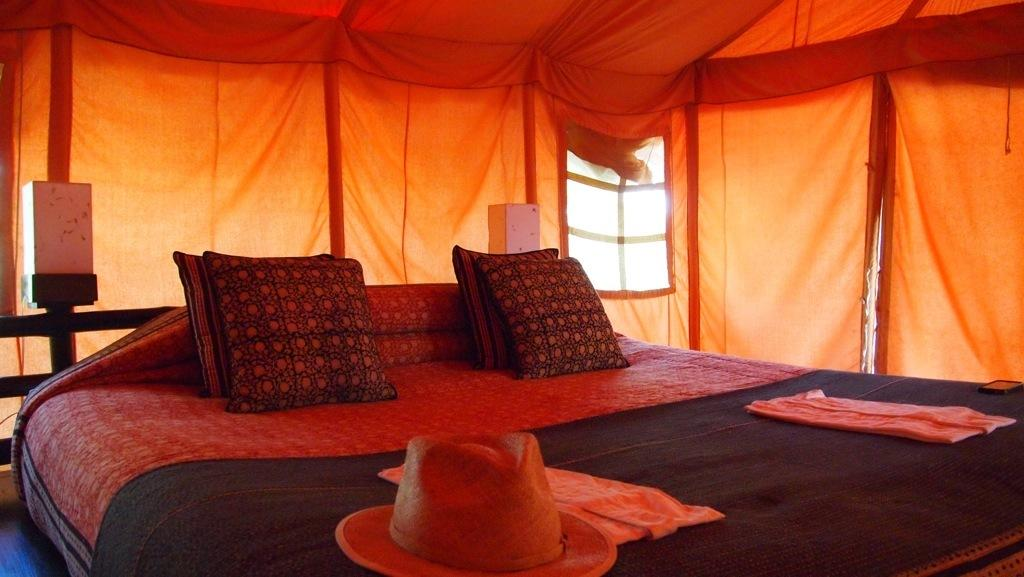What items can be seen on the bed in the image? There are pillows, a hat, and cloth on the bed. What type of fabric covers the bed? There is a bed sheet on the bed. What other objects are present in the image? There are boxes in the image. What color tint is visible at the top of the image? There is an orange color tint on the top of the image. How many rabbits can be seen playing with the liquid in the image? There are no rabbits or liquid present in the image. What is the afterthought of the person who placed the items on the bed? The image does not provide information about the person's intentions or afterthoughts. 